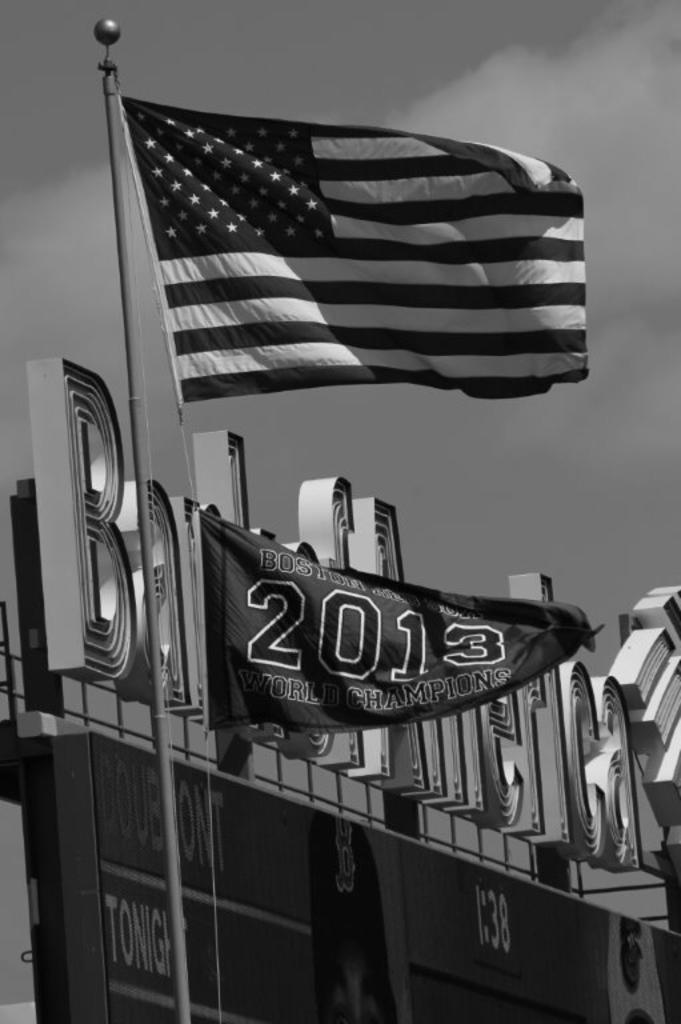What happened in 2013?
Make the answer very short. World champions. 